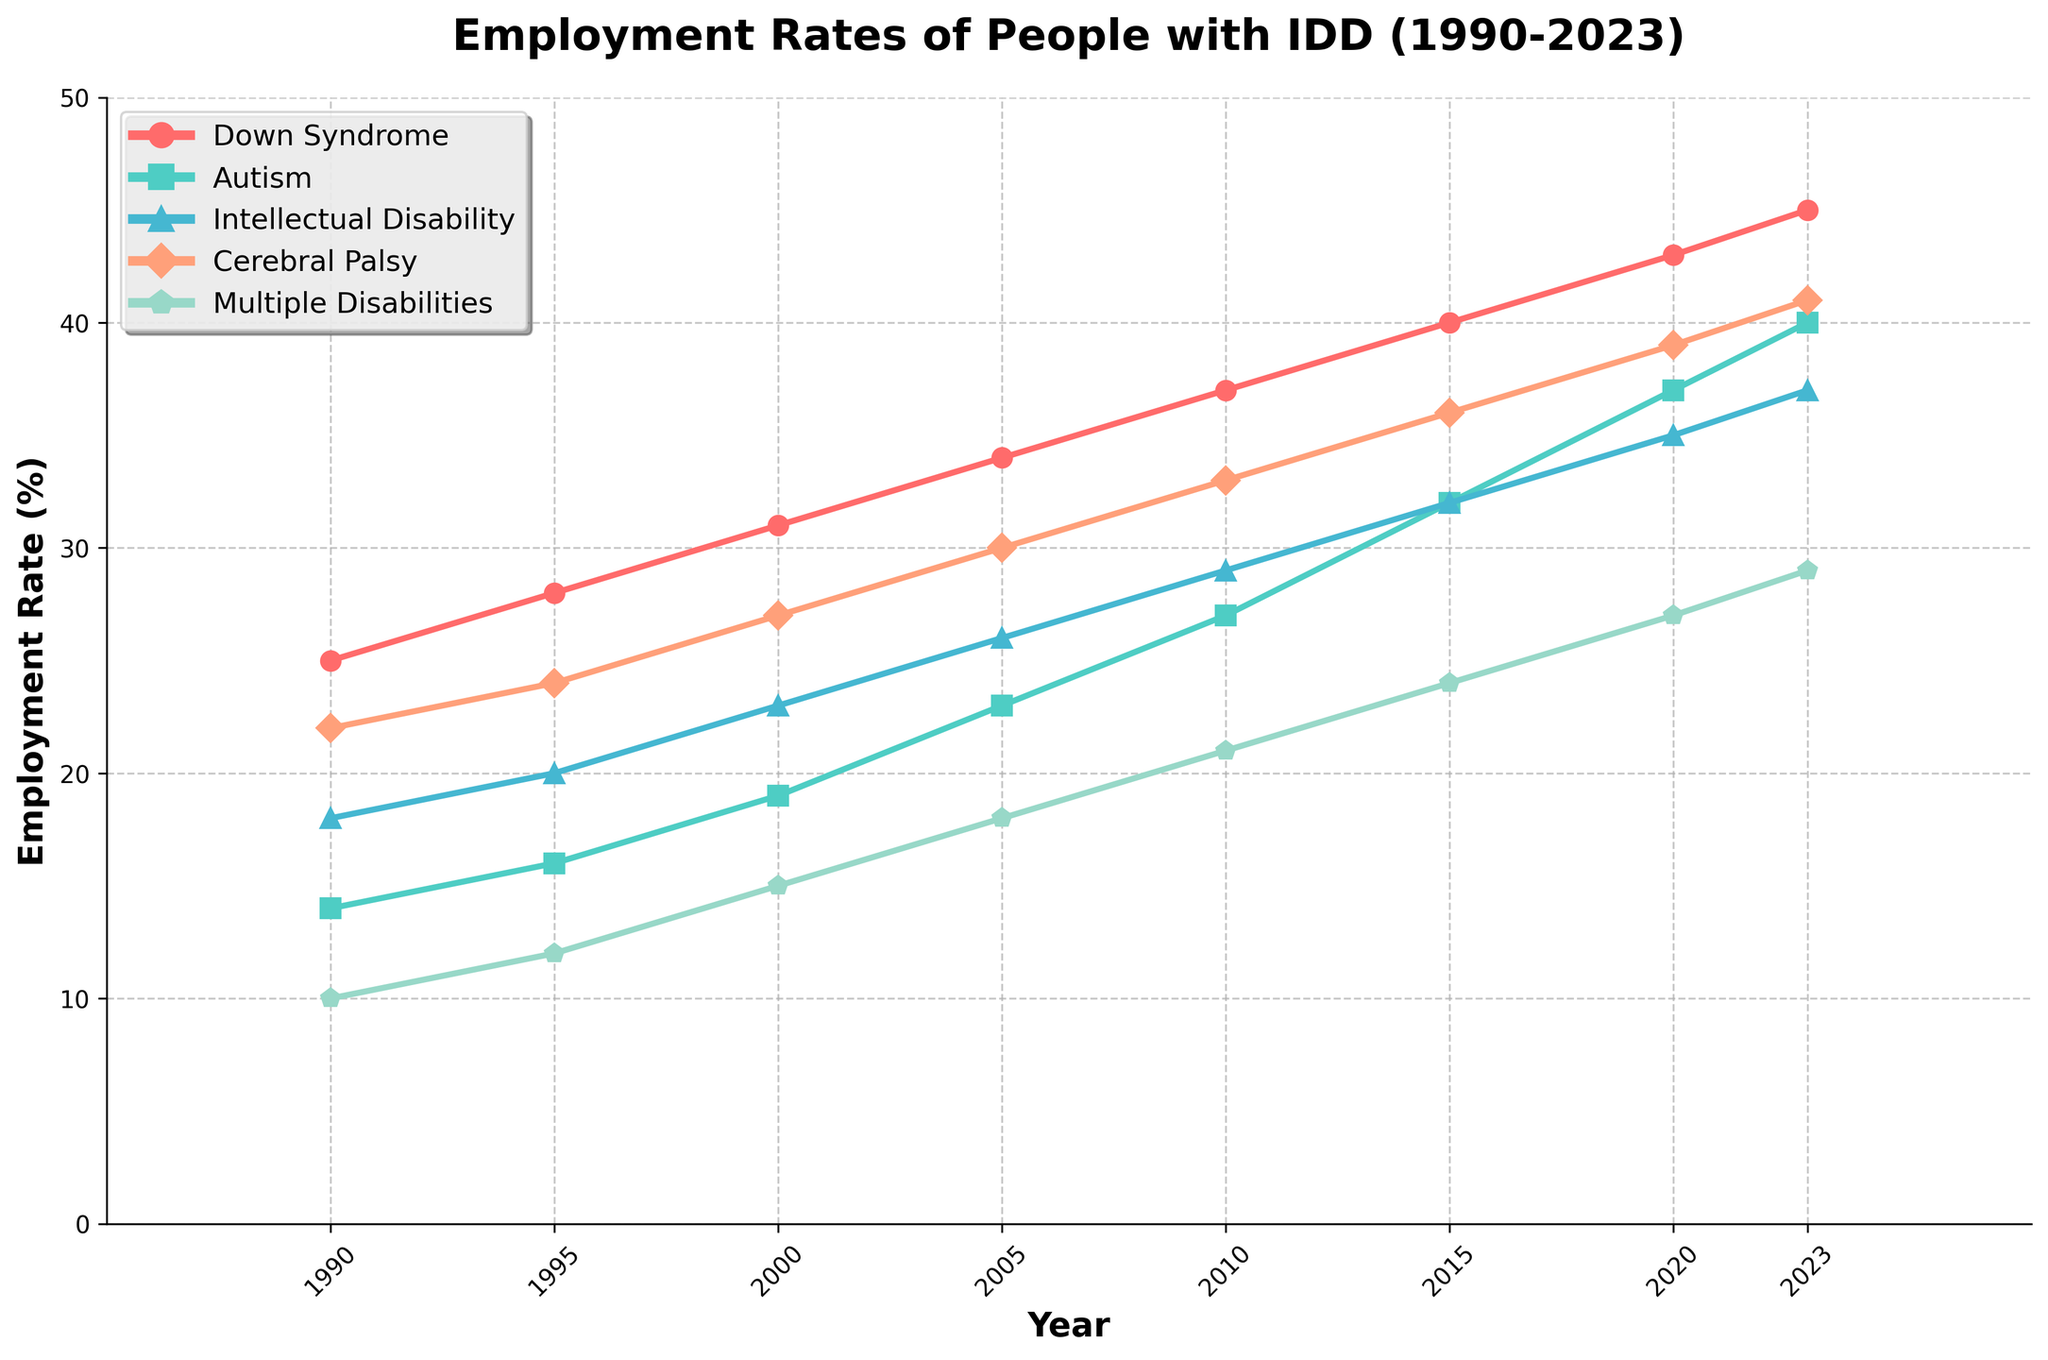Which year had the highest employment rate for people with Autism? Look for the peak point in the Autism line on the graph. The highest point for Autism is at 2023.
Answer: 2023 In which year did people with Down Syndrome and Intellectual Disability have the same employment rate? Look for the intersection points between the lines for Down Syndrome and Intellectual Disability. There are no intersecting points, so they did not have the same employment rate in any year.
Answer: Never What is the average employment rate for people with Down Syndrome in 1990 and 2000? Take the employment rates for Down Syndrome in 1990 and 2000 (25% and 31%, respectively), sum them, and then divide by 2. (25 + 31) / 2 = 56 / 2 = 28
Answer: 28 Calculate the difference in employment rates for people with Cerebral Palsy between 1990 and 2023. Subtract the 1990 value from the 2023 value for Cerebral Palsy. 41% - 22% = 19%
Answer: 19% Which disability group saw the largest increase in employment rate from 1990 to 2023? Calculate the increase for each group by subtracting the 1990 values from the 2023 values and identify the largest one. Down Syndrome: 45-25, Autism: 40-14, Intellectual Disability: 37-18, Cerebral Palsy: 41-22, Multiple Disabilities: 29-10. Largest increase is for Autism (26%).
Answer: Autism In 2010, which disability group had the second highest employment rate? Look at the values for 2010 and rank them. First highest is Down Syndrome (37%), second highest is Cerebral Palsy (33%).
Answer: Cerebral Palsy What is the median employment rate for all disability groups in the year 2005? List the employment rates for each group in 2005: 34, 23, 26, 30, 18. The median is the middle value when the rates are sorted: 34, 30, 26, 23, 18. Median is 26%.
Answer: 26% For which disability group does the employment rate increase the most uniformly (without decline) over the years? Identify the group with consistently increasing values in all time points. All groups have increasing values, but Down Syndrome has the most uniform increase.
Answer: Down Syndrome Compare the employment rates of people with Multiple Disabilities in 1990 and 2023. How much has it increased? Subtract the rate for Multiple Disabilities in 1990 from that in 2023: 29% - 10% = 19%
Answer: 19% In 2000, rank the employment rates from highest to lowest for all disability groups. Arrange the values for 2000 in descending order: 31 (Down Syndrome), 27 (Cerebral Palsy), 23 (Intellectual Disability), 19 (Autism), 15 (Multiple Disabilities).
Answer: Down Syndrome, Cerebral Palsy, Intellectual Disability, Autism, Multiple Disabilities 